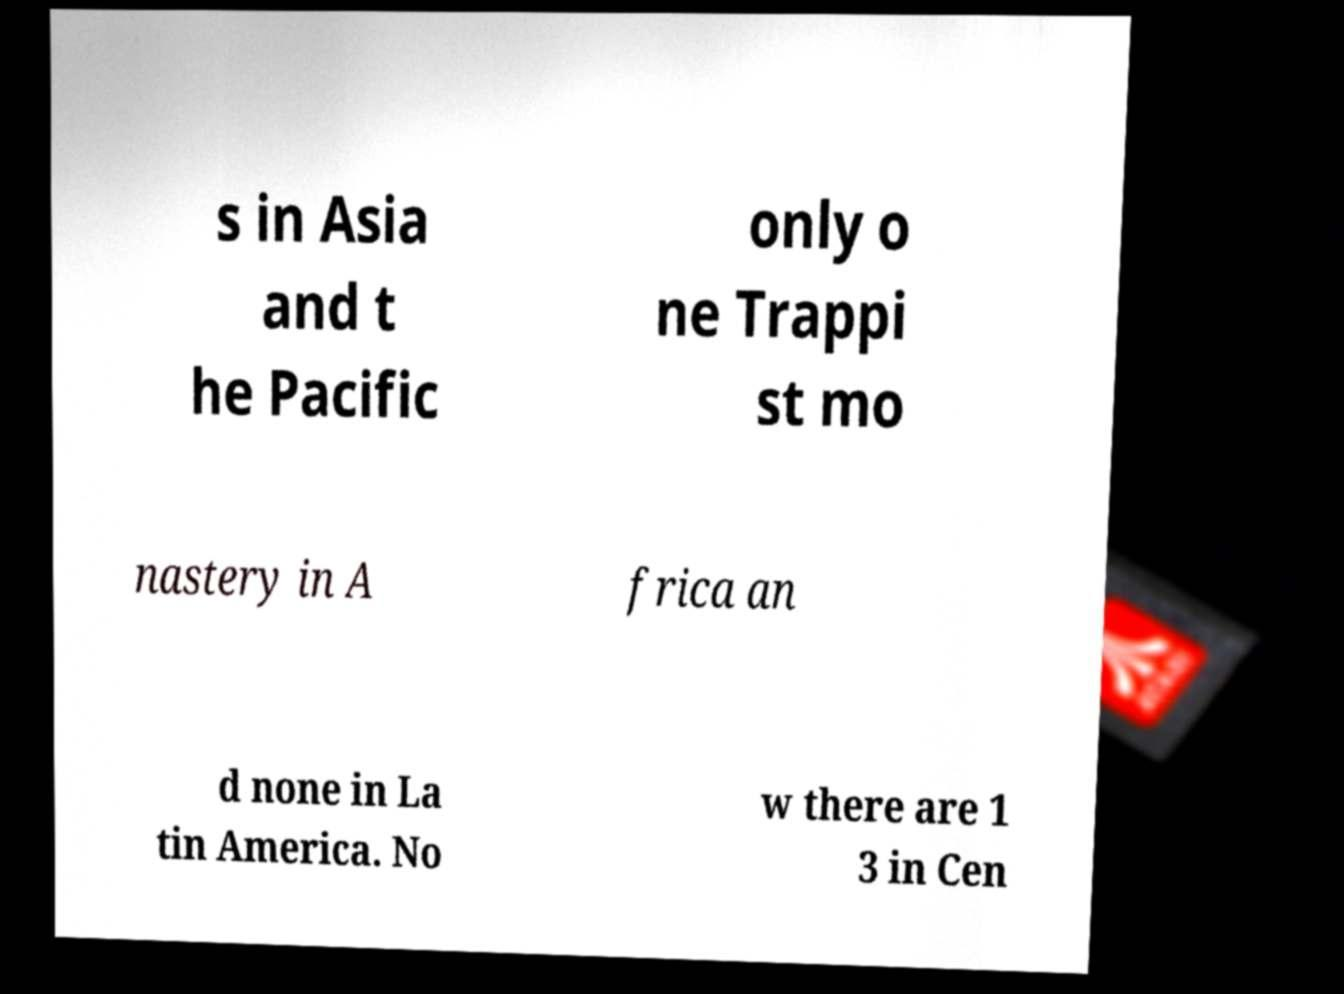There's text embedded in this image that I need extracted. Can you transcribe it verbatim? s in Asia and t he Pacific only o ne Trappi st mo nastery in A frica an d none in La tin America. No w there are 1 3 in Cen 